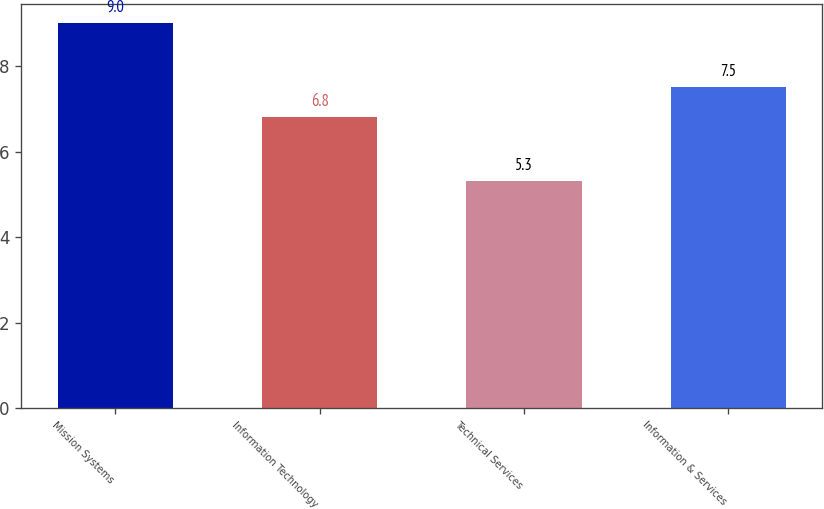Convert chart. <chart><loc_0><loc_0><loc_500><loc_500><bar_chart><fcel>Mission Systems<fcel>Information Technology<fcel>Technical Services<fcel>Information & Services<nl><fcel>9<fcel>6.8<fcel>5.3<fcel>7.5<nl></chart> 